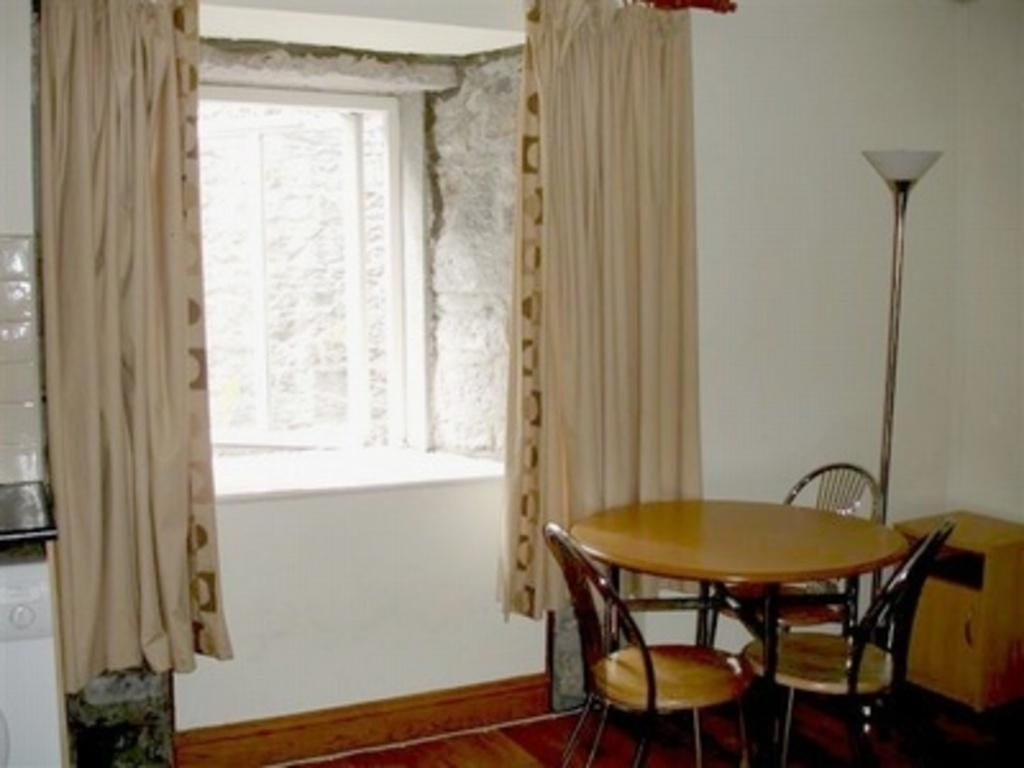What type of furniture is present in the image? There is a table and chairs near the table in the image. What other piece of furniture can be seen in the image? There is a desk in the image. Is there any source of light in the image? Yes, there is a light in the image. What can be found near the window in the image? There is a window with curtains in the image. Can you tell me how many goats are sitting on the chairs in the image? There are no goats present in the image; it features a table, chairs, a desk, a light, and a window with curtains. Is the user driving a car in the image? There is no car or driving activity depicted in the image. 